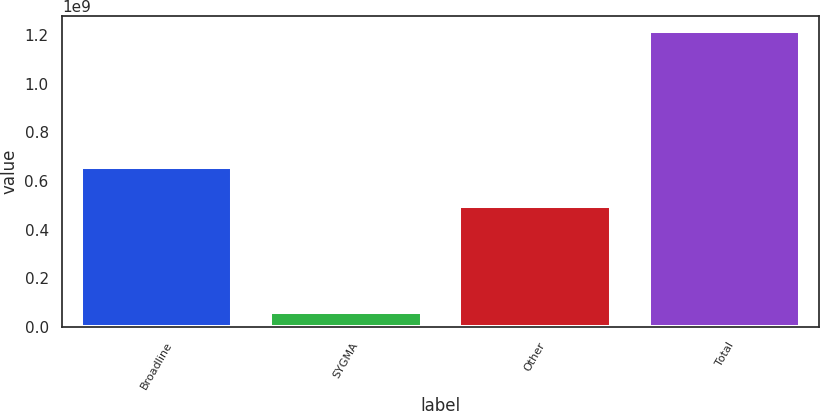Convert chart. <chart><loc_0><loc_0><loc_500><loc_500><bar_chart><fcel>Broadline<fcel>SYGMA<fcel>Other<fcel>Total<nl><fcel>6.58075e+08<fcel>6.1851e+07<fcel>4.98774e+08<fcel>1.2187e+09<nl></chart> 